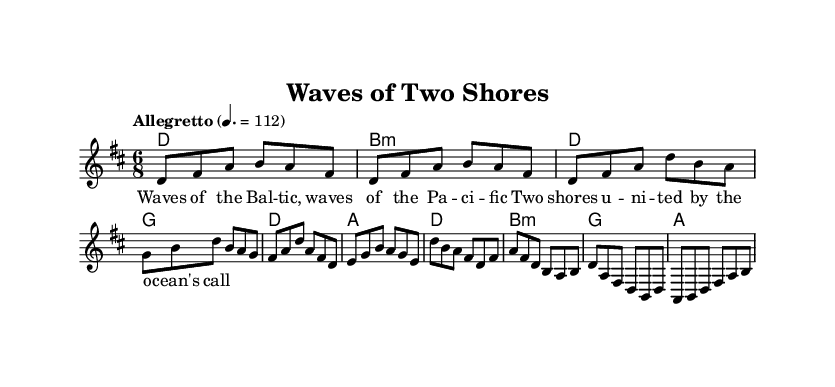What is the key signature of this music? The key signature is indicated by the number of sharps or flats at the beginning of the staff. In this case, there are two sharps (F# and C#), which corresponds to the key of D major.
Answer: D major What is the time signature of this music? The time signature is shown as a fraction at the beginning of the music, where the top number represents how many beats are in a measure and the bottom number indicates the note value that represents one beat. Here, the time signature is 6/8, meaning there are 6 eighth notes per measure.
Answer: 6/8 What is the tempo of this music? The tempo is specified in beats per minute, which provides an indication of how fast the piece should be played. In this case, the tempo marking is "Allegretto" with a metronome marking of 112 beats per minute.
Answer: 112 What is the main theme of the lyrics in this piece? The lyrics are usually found below the melody line and give insight into the song's content. The phrase "Waves of the Baltic, waves of the Pacific" suggests that the main theme is about the ocean and the unification of different shores.
Answer: Ocean themes How many measures are in the chorus section? The chorus is indicated by the structure in the sheet music. By counting the measures in the chorus section, we see that there are 4 measures from the notation provided.
Answer: 4 measures What types of harmonies are used in the chords? The chord symbols in the music can give us information about the type of harmonies used, such as major or minor. The presence of both D major and B minor chords indicates a blend of major and minor harmonies, typical for folk music.
Answer: Major and minor 